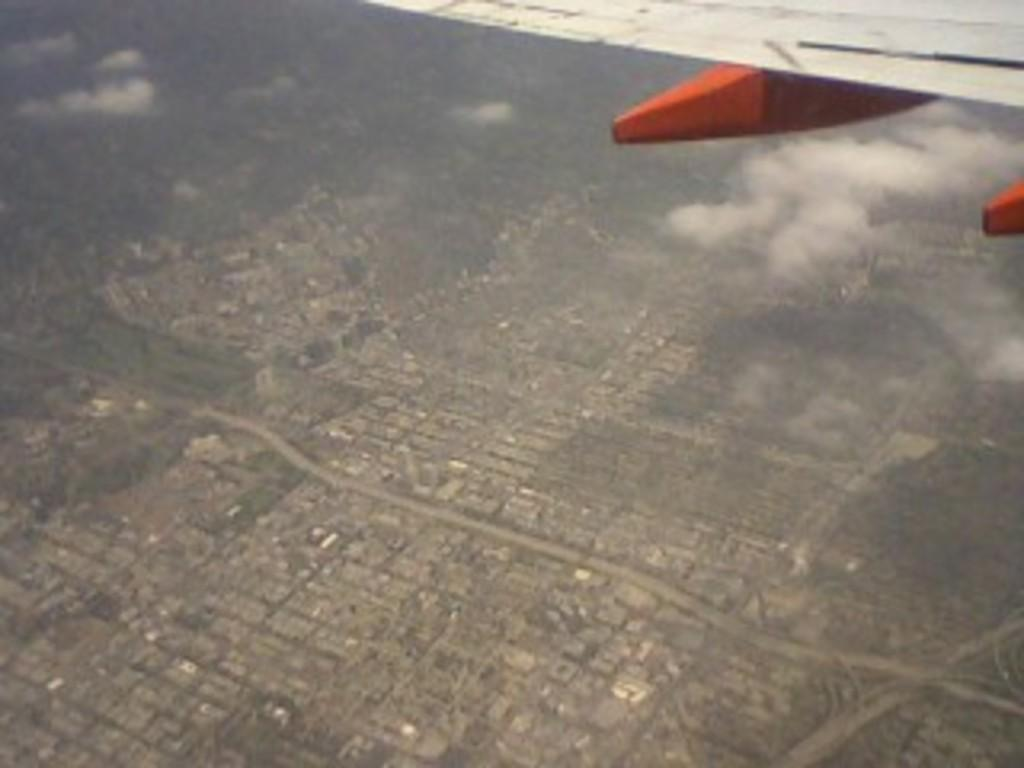What type of view is provided in the image? The image is a top view from a plane. What can be seen from this perspective? There are buildings visible in the image. Where is the basketball court located in the image? There is no basketball court visible in the image; it only shows buildings from a top view. What type of jam is being spread on the bread in the image? There is no bread or jam present in the image; it only shows buildings from a top view. 